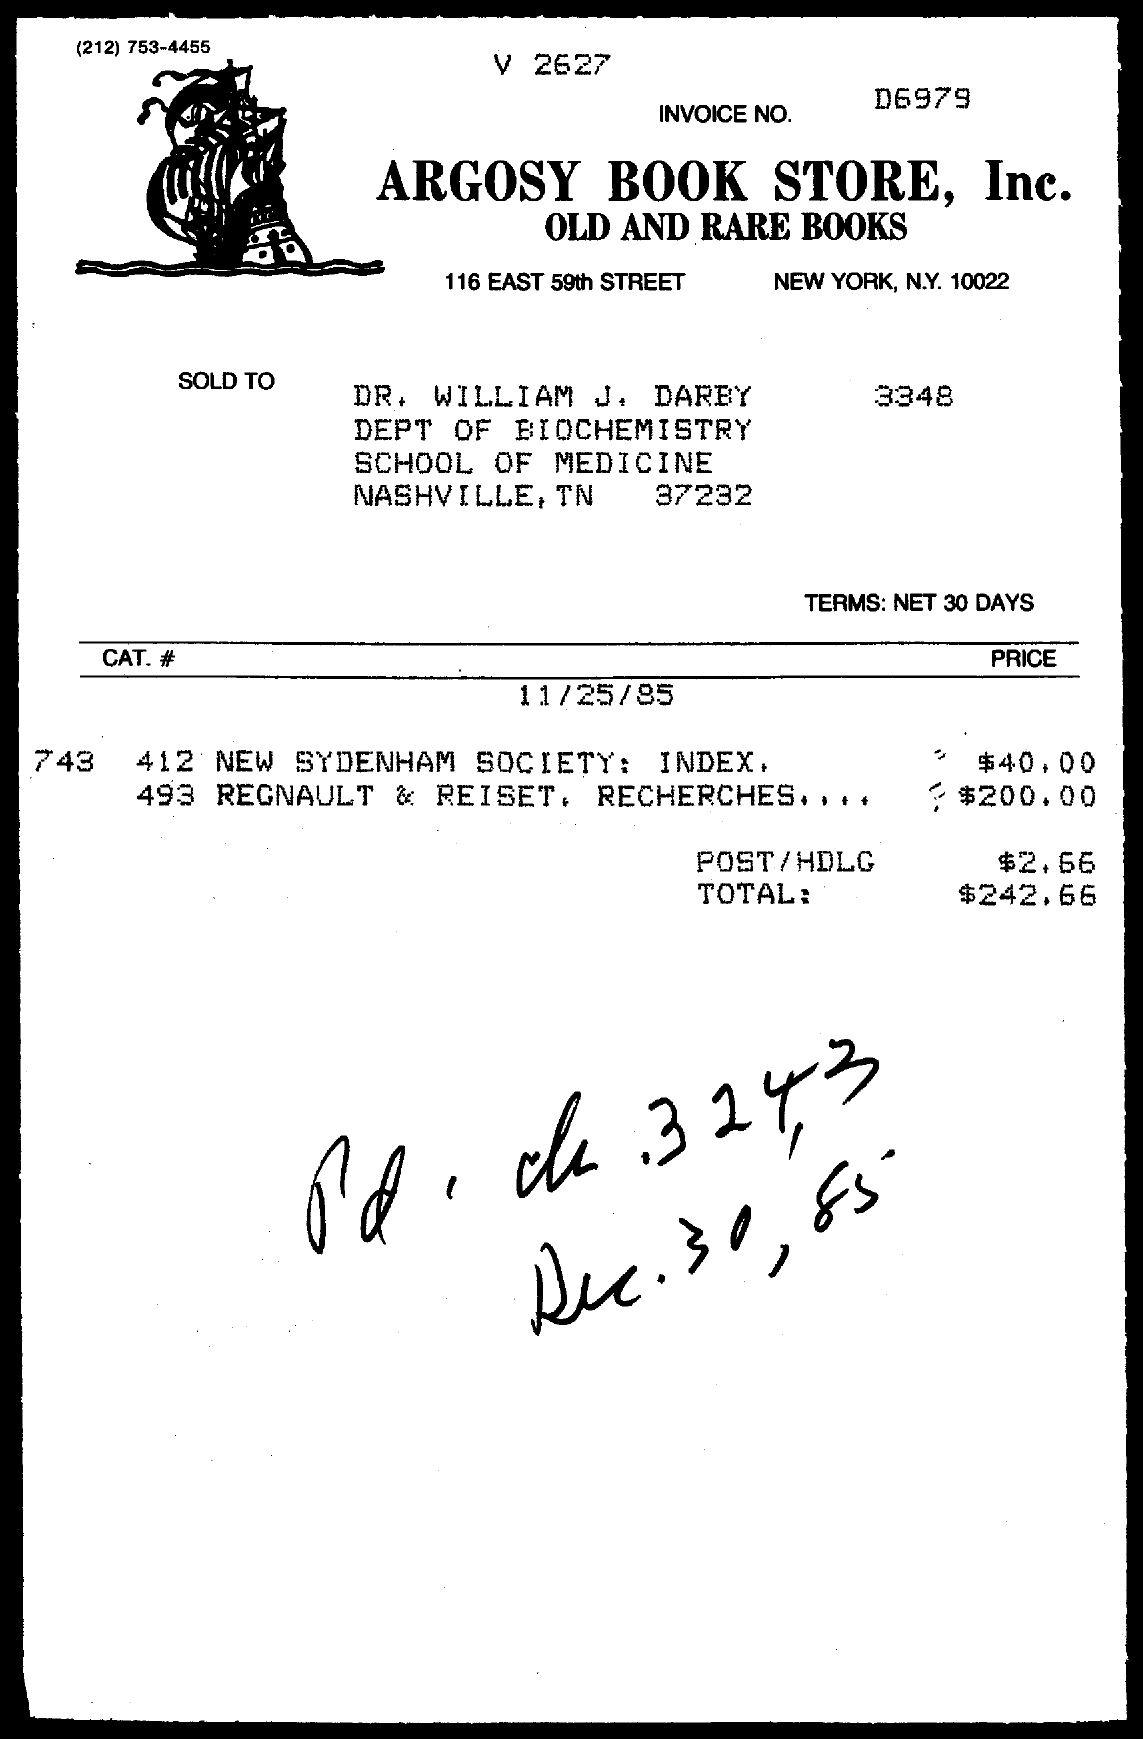What is the Invoice No.?
Provide a succinct answer. D6979. What is the handwritten date at the bottom?
Make the answer very short. Dec.30, 85. 